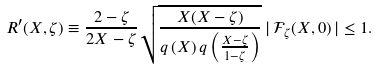Convert formula to latex. <formula><loc_0><loc_0><loc_500><loc_500>R ^ { \prime } ( X , \zeta ) \equiv \frac { 2 - \zeta } { 2 X - \zeta } \sqrt { \frac { X ( X - \zeta ) } { q \left ( X \right ) q \left ( \frac { X - \zeta } { 1 - \zeta } \right ) } } \, | \, \mathcal { F } _ { \zeta } ( X , 0 ) \, | \leq 1 .</formula> 